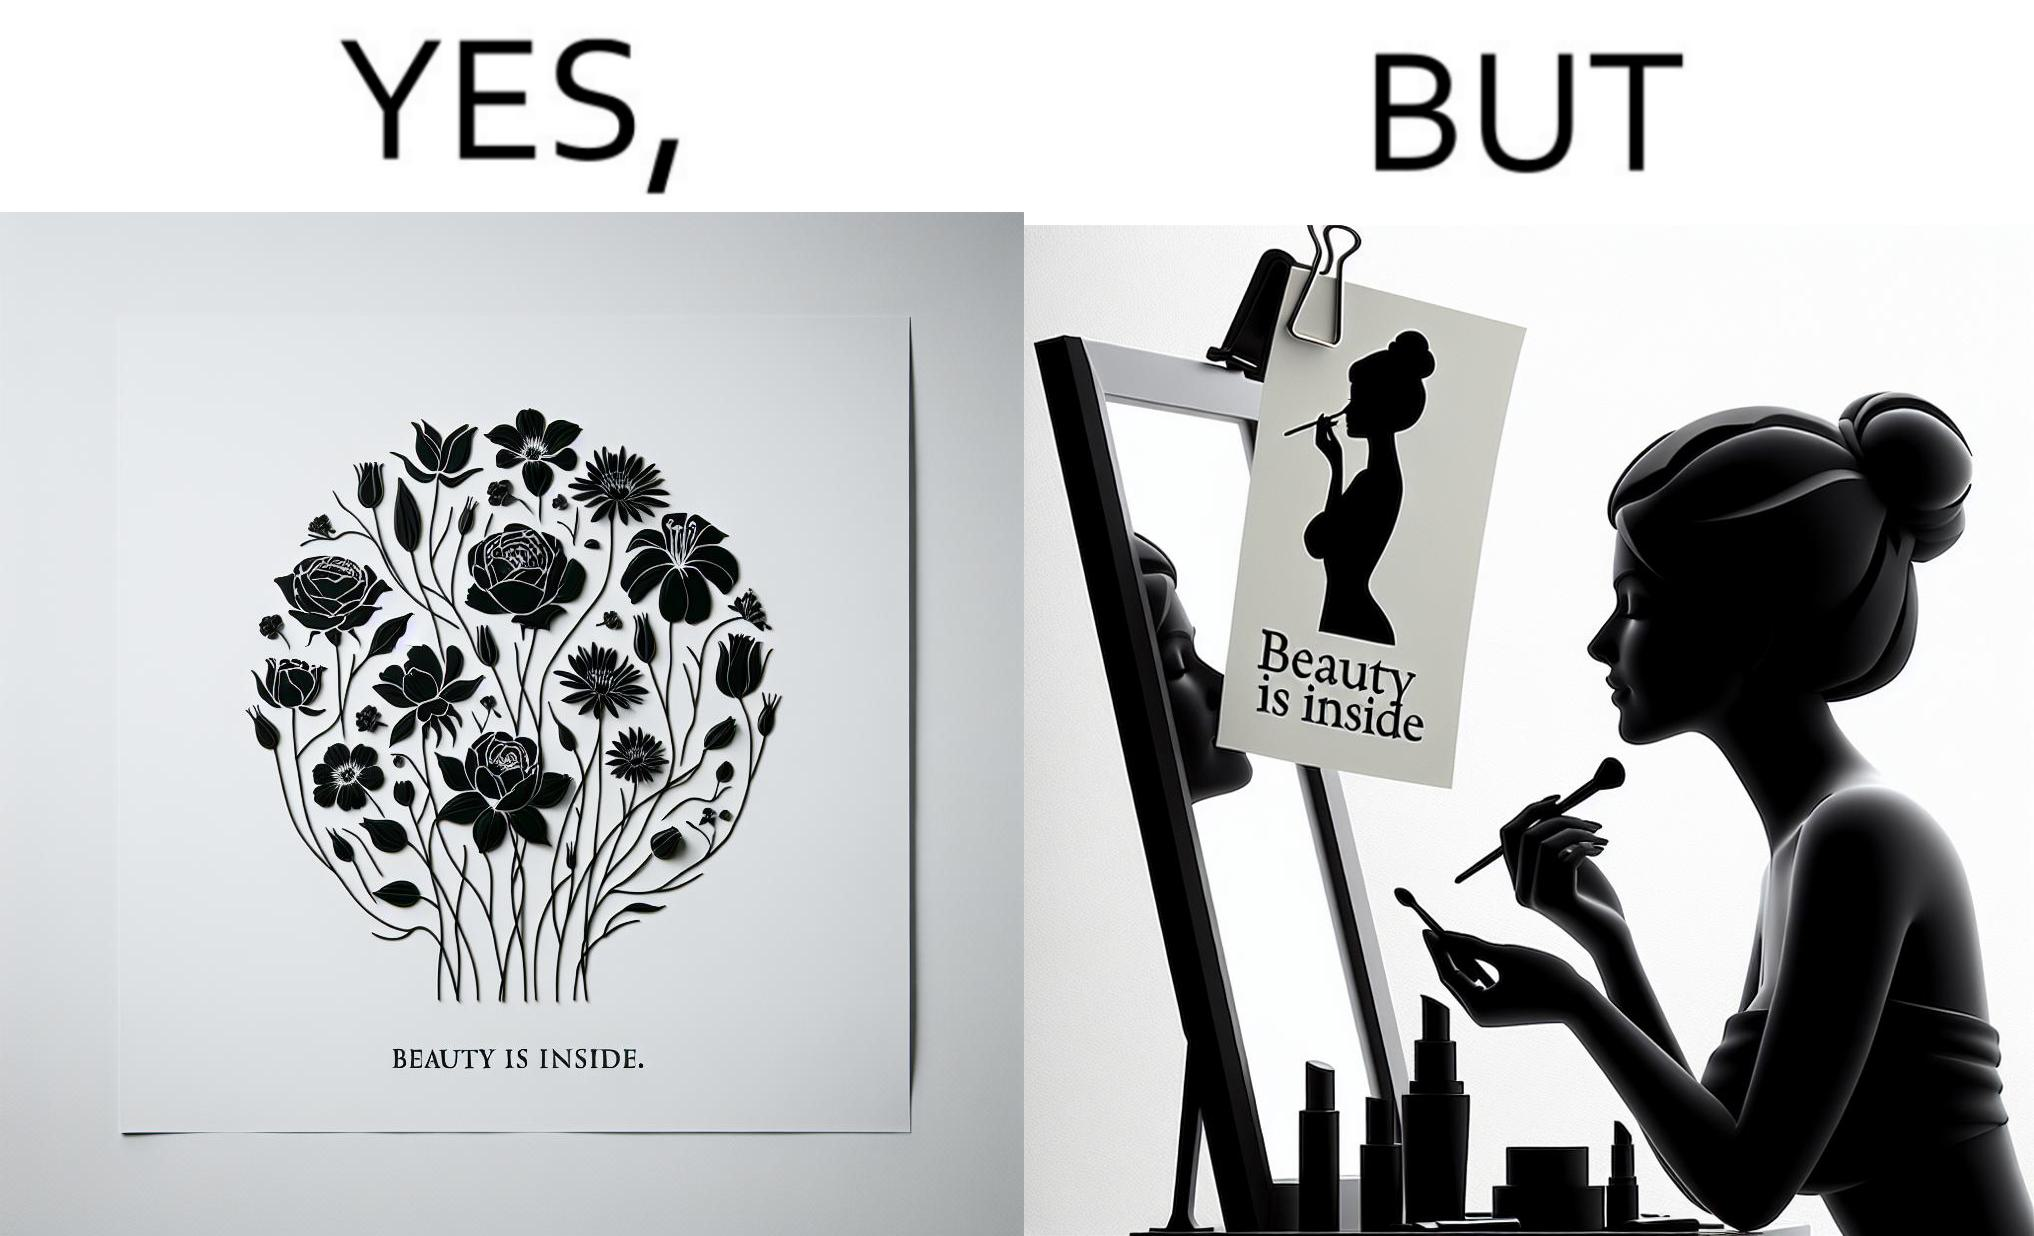Compare the left and right sides of this image. In the left part of the image: The image shows a text in beautiful font with flowers drawn around it. The text says "Beauty Is Inside". In the right part of the image: The image shows a woman applying makeup after shower by looking at herself in the dressing mirror. A piece of paper that says "Beauty is Inside" is clipped to the top of the mirror. 